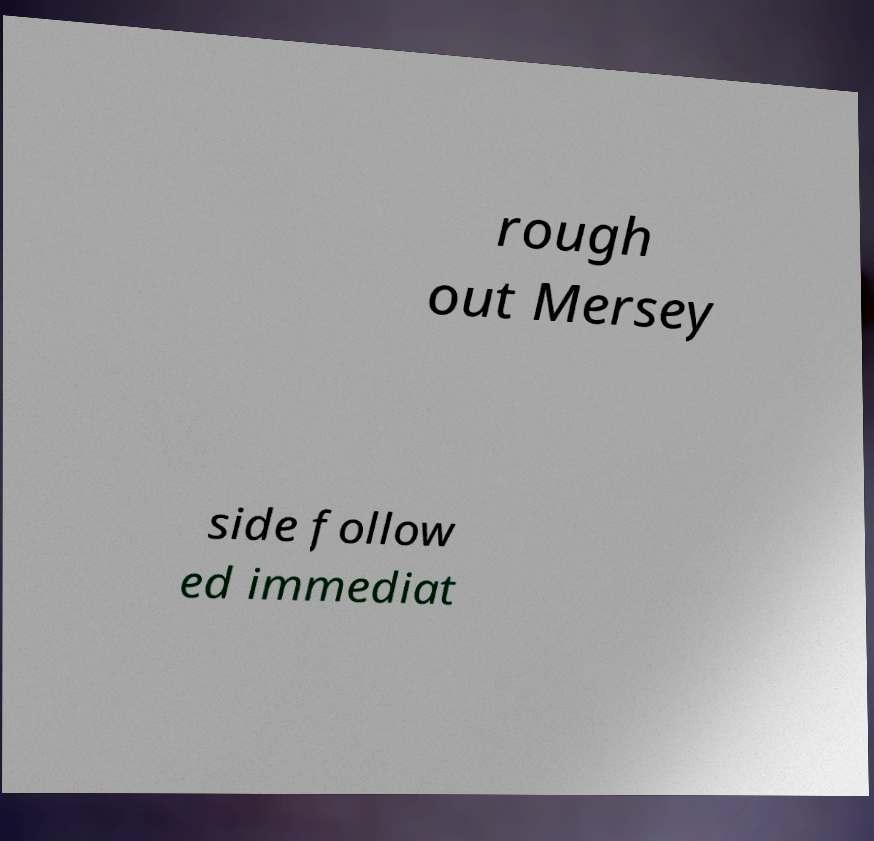I need the written content from this picture converted into text. Can you do that? rough out Mersey side follow ed immediat 